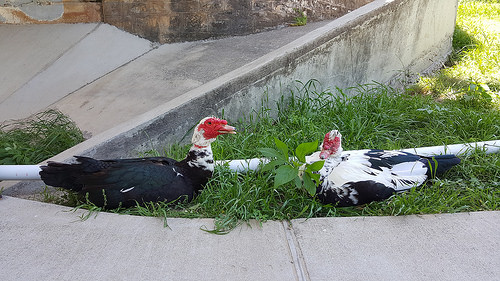<image>
Is the duck on the sidewalk? No. The duck is not positioned on the sidewalk. They may be near each other, but the duck is not supported by or resting on top of the sidewalk. 